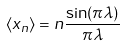<formula> <loc_0><loc_0><loc_500><loc_500>\langle x _ { n } \rangle = n \frac { \sin ( \pi \lambda ) } { \pi \lambda }</formula> 